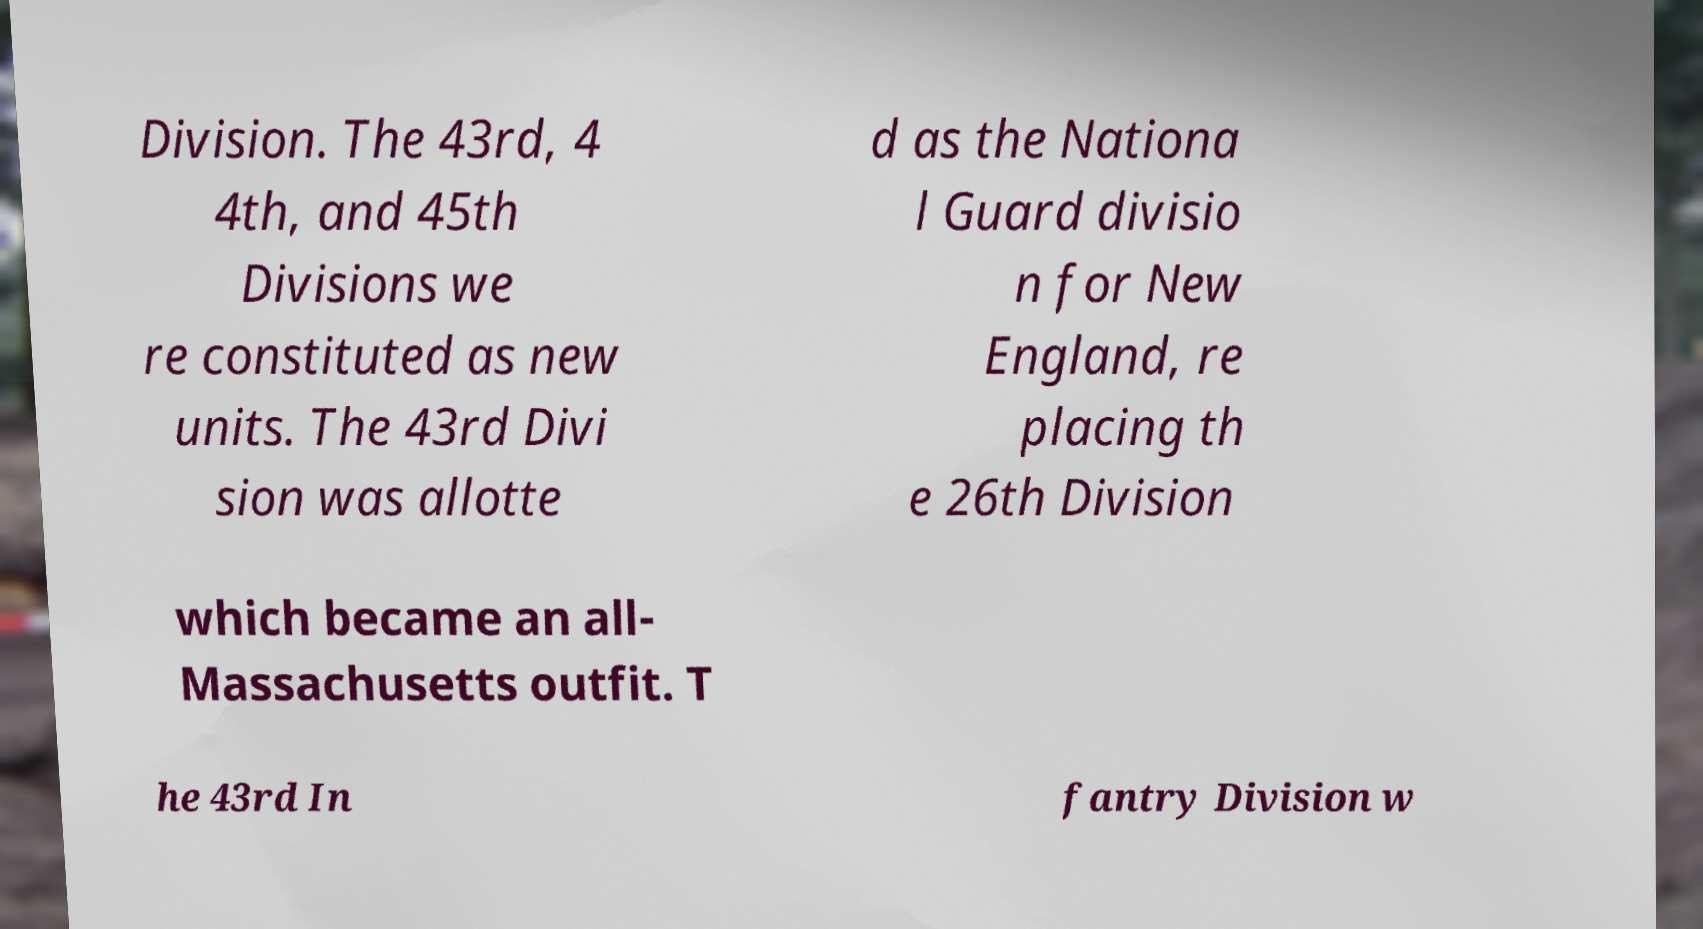For documentation purposes, I need the text within this image transcribed. Could you provide that? Division. The 43rd, 4 4th, and 45th Divisions we re constituted as new units. The 43rd Divi sion was allotte d as the Nationa l Guard divisio n for New England, re placing th e 26th Division which became an all- Massachusetts outfit. T he 43rd In fantry Division w 